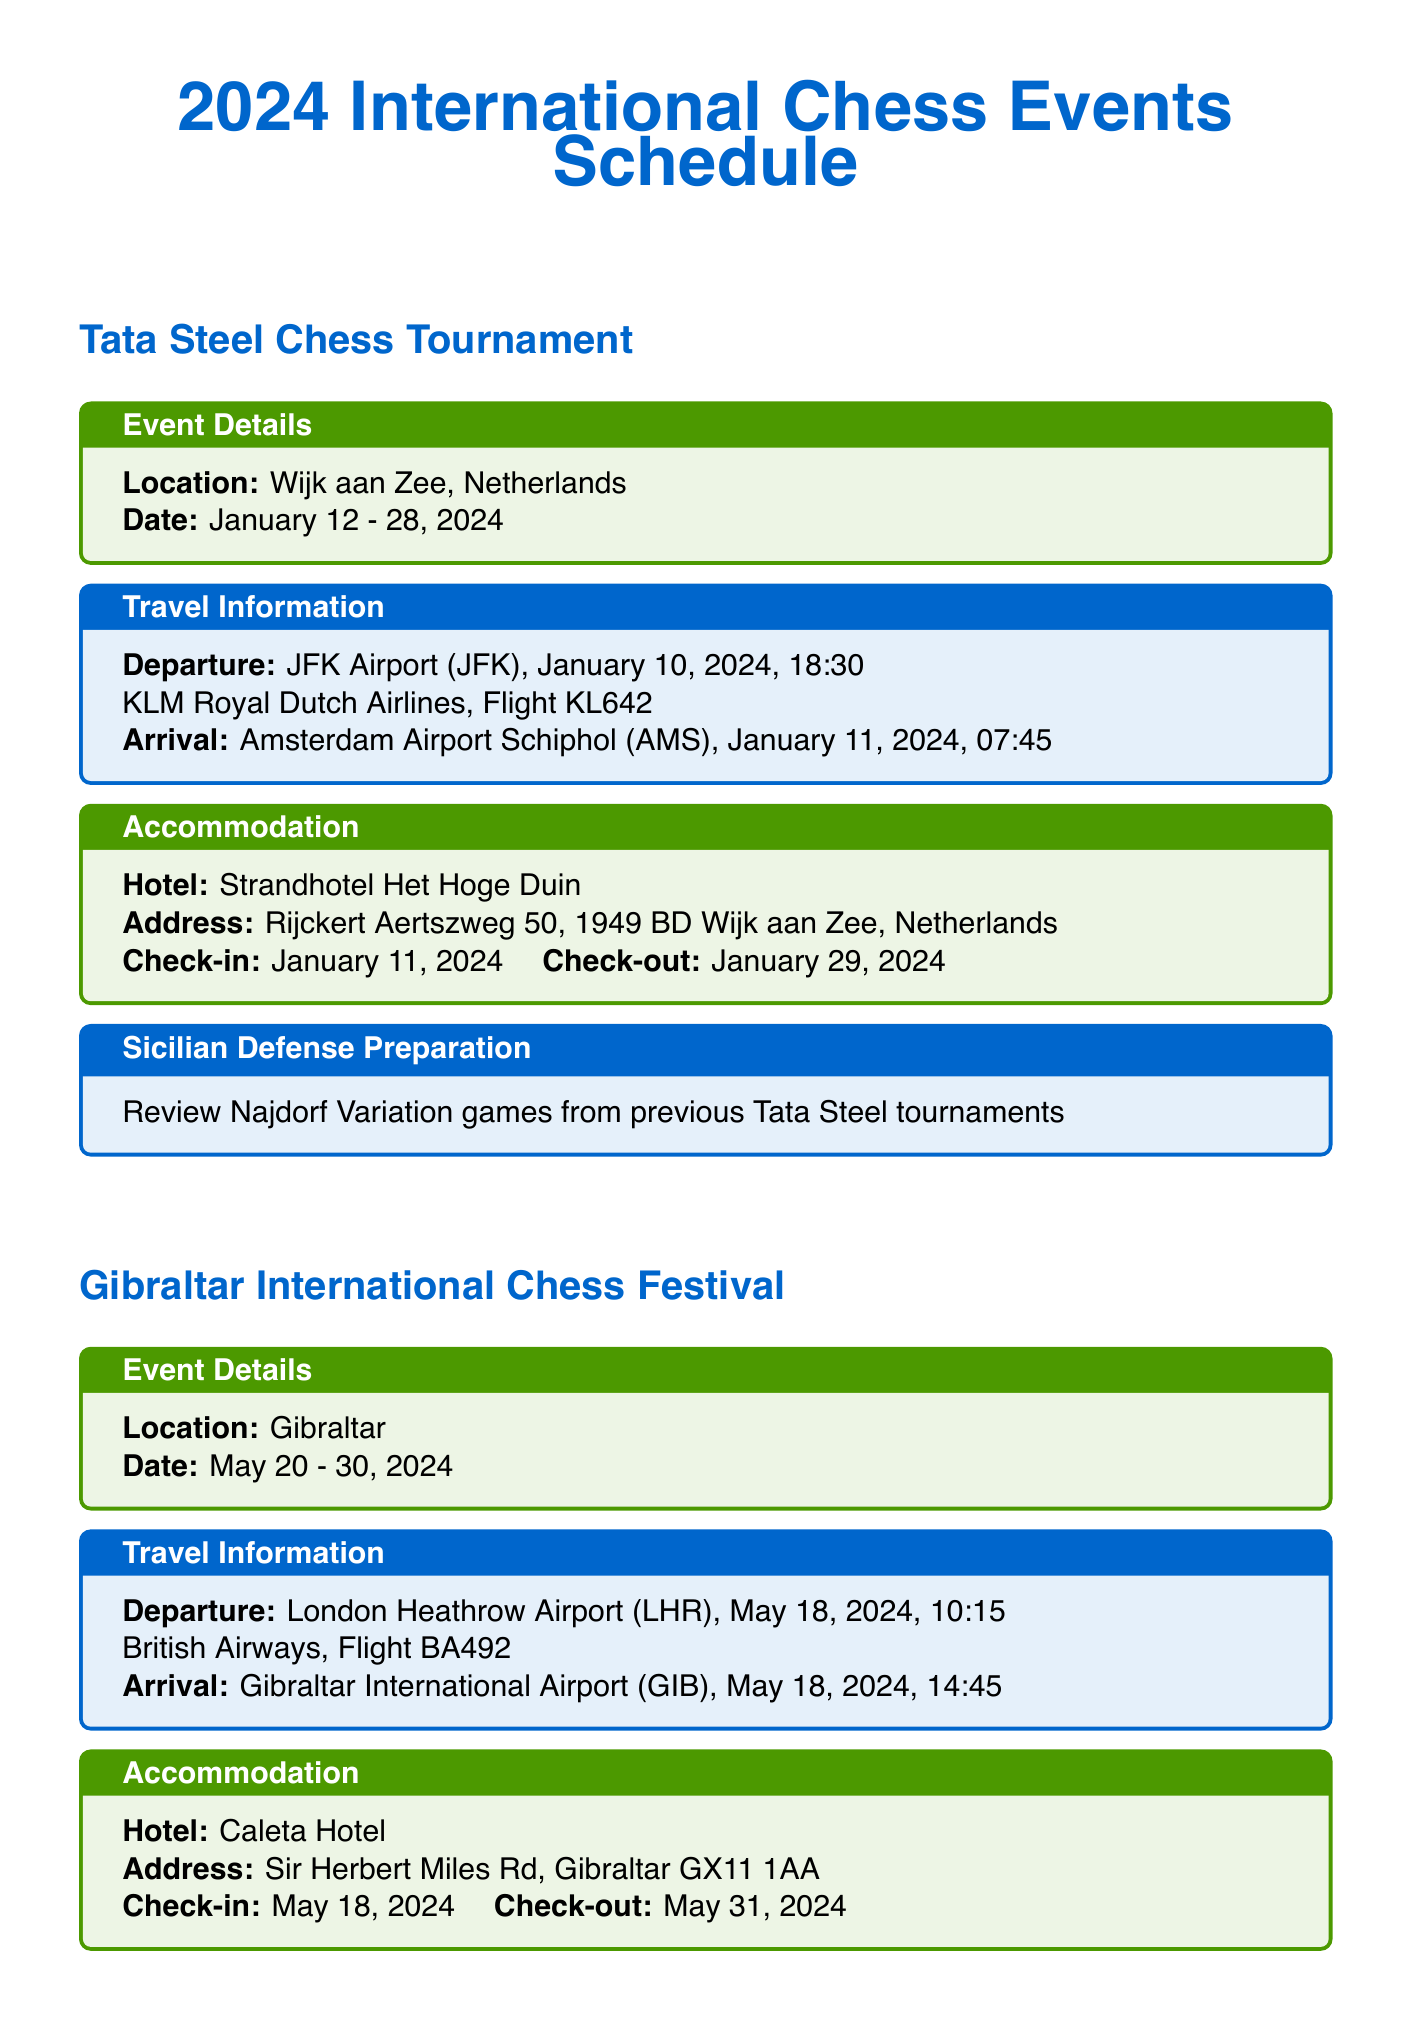What is the location of the Tata Steel Chess Tournament? The location is specified under the event details section of the Tata Steel Chess Tournament.
Answer: Wijk aan Zee, Netherlands What is the check-out date for the hotel at the Gibraltar International Chess Festival? The check-out date is mentioned in the accommodation section of the Gibraltar International Chess Festival.
Answer: May 31, 2024 Which airline is providing the flight to the Moscow Chess Open? The airline is listed in the travel information section for the Moscow Chess Open.
Answer: Aeroflot What is the departure airport for the Isle of Man International Chess Tournament? The departure airport is included in the travel information for the Isle of Man International Chess Tournament.
Answer: Manchester Airport How many days does the Gibraltar International Chess Festival last? The duration of the festival can be calculated from the given start and end dates.
Answer: 11 days What Sicilian Defense preparation is recommended for the Tata Steel Chess Tournament? This preparation is noted in the Sicilian Defense preparation section for the Tata Steel Chess Tournament.
Answer: Review Najdorf Variation games from previous Tata Steel tournaments What is the flight number for KLM on the way to the Tata Steel Chess Tournament? The flight number is present in the travel information section of the Tata Steel event.
Answer: KL642 What is the address of the hotel for the Moscow Chess Open? The hotel address is provided under the accommodation section of the Moscow Chess Open.
Answer: Teatralny Proezd, 2, Moscow 109012, Russia What type of chess equipment is listed in the document? The document specifies a list of equipment in a section dedicated to chess equipment.
Answer: DGT 3000 chess clock, Wooden Staunton chess set, Scoresheet booklet, Chess.com Premium account for online analysis 